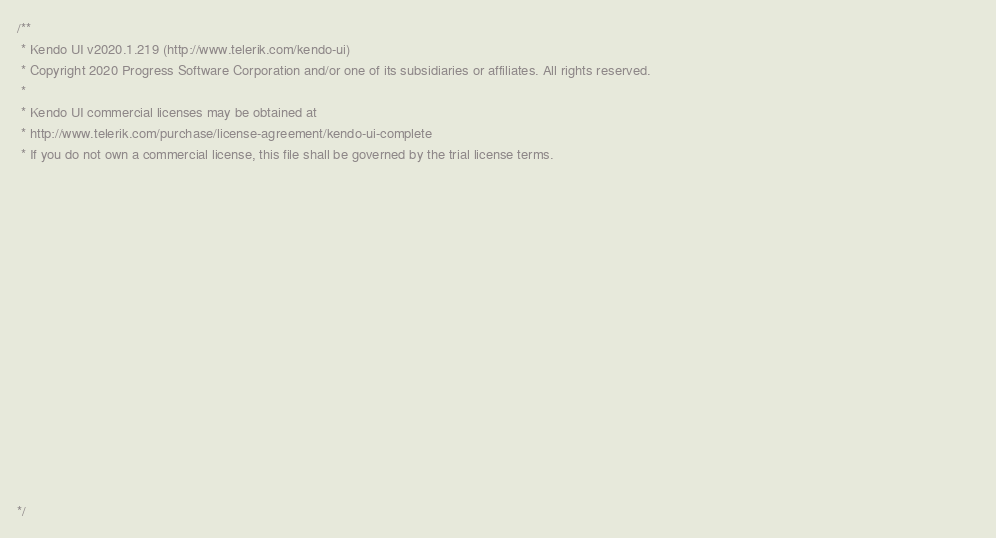<code> <loc_0><loc_0><loc_500><loc_500><_JavaScript_>/** 
 * Kendo UI v2020.1.219 (http://www.telerik.com/kendo-ui)                                                                                                                                               
 * Copyright 2020 Progress Software Corporation and/or one of its subsidiaries or affiliates. All rights reserved.                                                                                      
 *                                                                                                                                                                                                      
 * Kendo UI commercial licenses may be obtained at                                                                                                                                                      
 * http://www.telerik.com/purchase/license-agreement/kendo-ui-complete                                                                                                                                  
 * If you do not own a commercial license, this file shall be governed by the trial license terms.                                                                                                      
                                                                                                                                                                                                       
                                                                                                                                                                                                       
                                                                                                                                                                                                       
                                                                                                                                                                                                       
                                                                                                                                                                                                       
                                                                                                                                                                                                       
                                                                                                                                                                                                       
                                                                                                                                                                                                       
                                                                                                                                                                                                       
                                                                                                                                                                                                       
                                                                                                                                                                                                       
                                                                                                                                                                                                       
                                                                                                                                                                                                       
                                                                                                                                                                                                       
                                                                                                                                                                                                       

*/</code> 